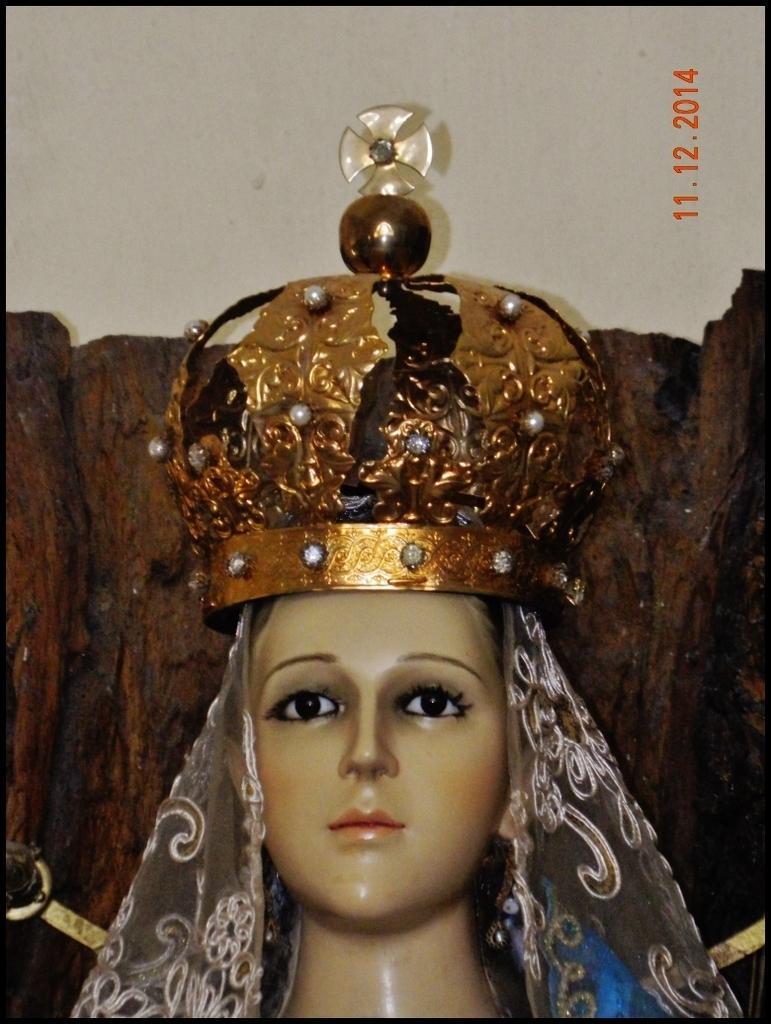Can you describe this image briefly? In this image we can see a sculpture of a lady. There is some text on the right side of the image. 